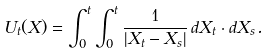Convert formula to latex. <formula><loc_0><loc_0><loc_500><loc_500>U _ { t } ( X ) = \int _ { 0 } ^ { t } \int _ { 0 } ^ { t } \frac { 1 } { | X _ { t } - X _ { s } | } \, d X _ { t } \cdot d X _ { s } .</formula> 